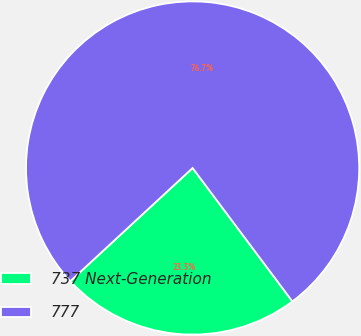Convert chart to OTSL. <chart><loc_0><loc_0><loc_500><loc_500><pie_chart><fcel>737 Next-Generation<fcel>777<nl><fcel>23.34%<fcel>76.66%<nl></chart> 